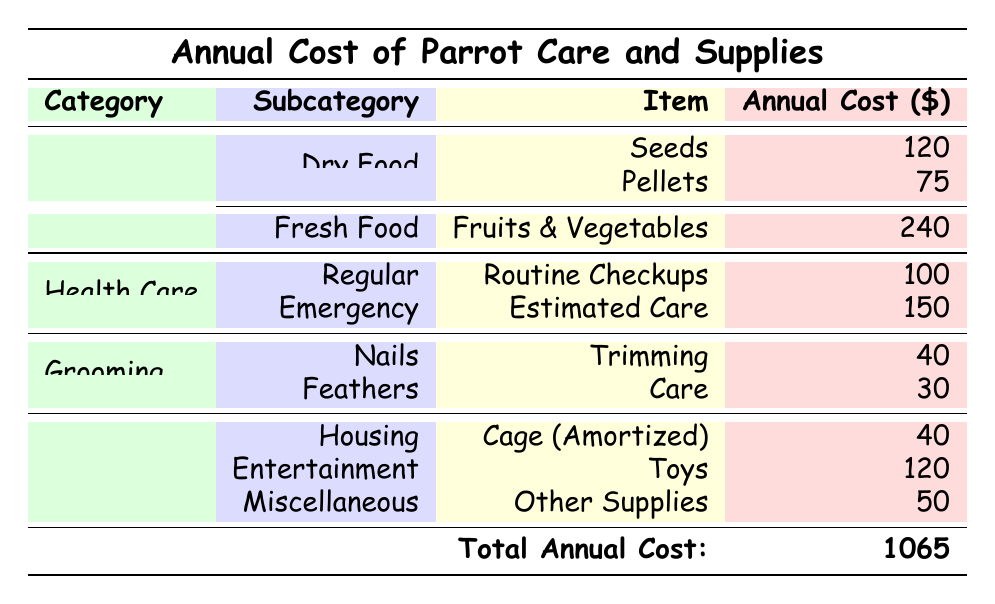What is the total cost of feeding a parrot annually? To find the total cost of feeding, we need to sum the annual costs of seeds, pellets, and fresh fruits & vegetables. The total is 120 (seeds) + 75 (pellets) + 240 (fruits & vegetables) = 435.
Answer: 435 How much does emergency veterinary care cost per year? The table specifies that the estimated annual cost for emergency veterinary care is 150.
Answer: 150 Is the cost of grooming higher than the cost of health care? The grooming cost totals 70 (40 for nail trimming and 30 for feather care) while the health care cost totals 250 (100 for routine checkups and 150 for emergency care). Since 70 is less than 250, the statement is false.
Answer: No What is the total cost of supplies for a parrot annually? To get the total for supplies, we need to add the amortized cost of the cage (40), toys (120), and other supplies (50). The total calculation is 40 + 120 + 50 = 210.
Answer: 210 If you replace the cage every 5 years, what is the annual cost allocated to the cage? Since the cage costs 200 and lasts 5 years, the annual cost is calculated by dividing 200 by 5, which gives 40.
Answer: 40 What is the highest annual cost among the categories listed? By comparing the total annual costs across the four categories, we see that feeding costs 435, health care 250, grooming 70, and supplies 310. The highest cost is from feeding at 435.
Answer: 435 How much would it cost annually for routine veterinary checkups and nail trimming combined? To find this total, we add the annual cost of routine veterinary checkups (100) to the cost of nail trimming (40). The calculation is 100 + 40 = 140.
Answer: 140 Are the total supplies costs greater than the grooming costs? The total cost for supplies is 210 while grooming is 70. Since 210 is greater than 70, the statement is true.
Answer: Yes What is the overall total cost of parrot care and supplies per year? The overall total cost is provided in the last row of the table and is noted as 1065.
Answer: 1065 